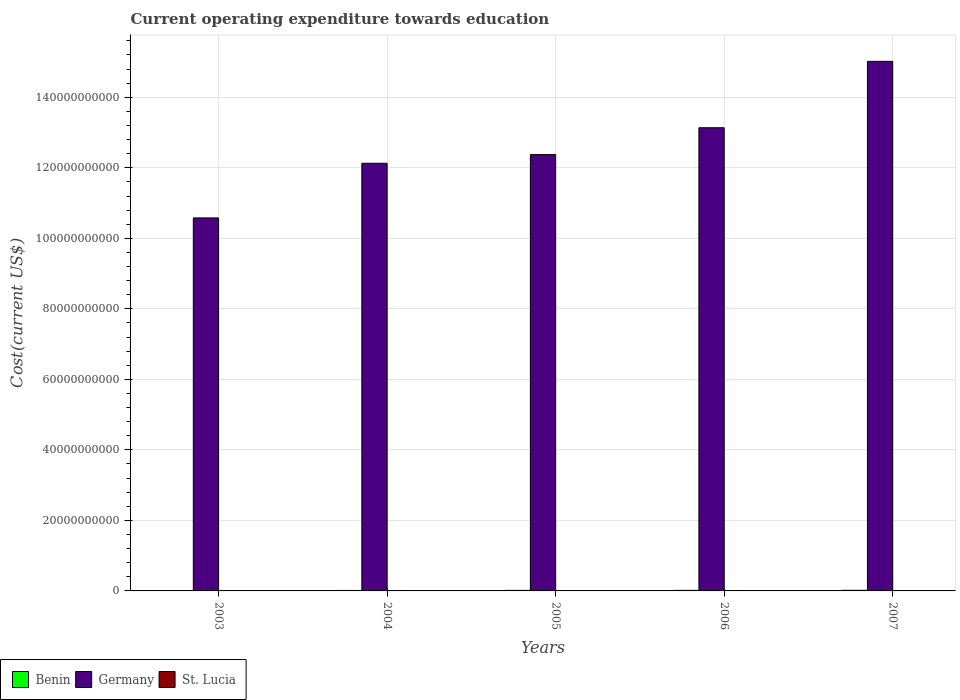Are the number of bars on each tick of the X-axis equal?
Provide a succinct answer. Yes. How many bars are there on the 5th tick from the right?
Offer a terse response. 3. What is the label of the 1st group of bars from the left?
Offer a very short reply. 2003. In how many cases, is the number of bars for a given year not equal to the number of legend labels?
Provide a short and direct response. 0. What is the expenditure towards education in St. Lucia in 2003?
Ensure brevity in your answer.  3.70e+07. Across all years, what is the maximum expenditure towards education in St. Lucia?
Provide a short and direct response. 4.95e+07. Across all years, what is the minimum expenditure towards education in Benin?
Keep it short and to the point. 9.85e+07. What is the total expenditure towards education in Benin in the graph?
Provide a succinct answer. 7.27e+08. What is the difference between the expenditure towards education in Germany in 2004 and that in 2007?
Your answer should be compact. -2.89e+1. What is the difference between the expenditure towards education in Germany in 2007 and the expenditure towards education in St. Lucia in 2004?
Provide a short and direct response. 1.50e+11. What is the average expenditure towards education in St. Lucia per year?
Make the answer very short. 4.30e+07. In the year 2004, what is the difference between the expenditure towards education in St. Lucia and expenditure towards education in Benin?
Give a very brief answer. -9.49e+07. What is the ratio of the expenditure towards education in St. Lucia in 2004 to that in 2007?
Your answer should be very brief. 0.76. Is the difference between the expenditure towards education in St. Lucia in 2006 and 2007 greater than the difference between the expenditure towards education in Benin in 2006 and 2007?
Your response must be concise. Yes. What is the difference between the highest and the second highest expenditure towards education in Benin?
Provide a short and direct response. 1.24e+07. What is the difference between the highest and the lowest expenditure towards education in St. Lucia?
Make the answer very short. 1.25e+07. What does the 3rd bar from the left in 2005 represents?
Your answer should be very brief. St. Lucia. What does the 1st bar from the right in 2004 represents?
Your response must be concise. St. Lucia. Are all the bars in the graph horizontal?
Keep it short and to the point. No. What is the difference between two consecutive major ticks on the Y-axis?
Your response must be concise. 2.00e+1. Does the graph contain any zero values?
Your answer should be very brief. No. Where does the legend appear in the graph?
Make the answer very short. Bottom left. How are the legend labels stacked?
Provide a short and direct response. Horizontal. What is the title of the graph?
Ensure brevity in your answer.  Current operating expenditure towards education. What is the label or title of the X-axis?
Offer a terse response. Years. What is the label or title of the Y-axis?
Your answer should be very brief. Cost(current US$). What is the Cost(current US$) in Benin in 2003?
Offer a very short reply. 9.85e+07. What is the Cost(current US$) in Germany in 2003?
Your answer should be compact. 1.06e+11. What is the Cost(current US$) of St. Lucia in 2003?
Make the answer very short. 3.70e+07. What is the Cost(current US$) of Benin in 2004?
Provide a short and direct response. 1.32e+08. What is the Cost(current US$) of Germany in 2004?
Give a very brief answer. 1.21e+11. What is the Cost(current US$) in St. Lucia in 2004?
Your answer should be very brief. 3.75e+07. What is the Cost(current US$) in Benin in 2005?
Keep it short and to the point. 1.56e+08. What is the Cost(current US$) in Germany in 2005?
Keep it short and to the point. 1.24e+11. What is the Cost(current US$) in St. Lucia in 2005?
Your response must be concise. 4.49e+07. What is the Cost(current US$) of Benin in 2006?
Offer a very short reply. 1.64e+08. What is the Cost(current US$) of Germany in 2006?
Your answer should be compact. 1.31e+11. What is the Cost(current US$) in St. Lucia in 2006?
Keep it short and to the point. 4.62e+07. What is the Cost(current US$) of Benin in 2007?
Your answer should be very brief. 1.76e+08. What is the Cost(current US$) in Germany in 2007?
Your answer should be compact. 1.50e+11. What is the Cost(current US$) in St. Lucia in 2007?
Ensure brevity in your answer.  4.95e+07. Across all years, what is the maximum Cost(current US$) in Benin?
Give a very brief answer. 1.76e+08. Across all years, what is the maximum Cost(current US$) of Germany?
Keep it short and to the point. 1.50e+11. Across all years, what is the maximum Cost(current US$) of St. Lucia?
Your response must be concise. 4.95e+07. Across all years, what is the minimum Cost(current US$) of Benin?
Your answer should be compact. 9.85e+07. Across all years, what is the minimum Cost(current US$) of Germany?
Offer a very short reply. 1.06e+11. Across all years, what is the minimum Cost(current US$) of St. Lucia?
Offer a terse response. 3.70e+07. What is the total Cost(current US$) in Benin in the graph?
Provide a succinct answer. 7.27e+08. What is the total Cost(current US$) in Germany in the graph?
Offer a terse response. 6.32e+11. What is the total Cost(current US$) in St. Lucia in the graph?
Your response must be concise. 2.15e+08. What is the difference between the Cost(current US$) of Benin in 2003 and that in 2004?
Keep it short and to the point. -3.39e+07. What is the difference between the Cost(current US$) in Germany in 2003 and that in 2004?
Your answer should be very brief. -1.55e+1. What is the difference between the Cost(current US$) of St. Lucia in 2003 and that in 2004?
Provide a short and direct response. -5.53e+05. What is the difference between the Cost(current US$) in Benin in 2003 and that in 2005?
Give a very brief answer. -5.77e+07. What is the difference between the Cost(current US$) of Germany in 2003 and that in 2005?
Provide a short and direct response. -1.80e+1. What is the difference between the Cost(current US$) in St. Lucia in 2003 and that in 2005?
Your response must be concise. -7.88e+06. What is the difference between the Cost(current US$) in Benin in 2003 and that in 2006?
Give a very brief answer. -6.51e+07. What is the difference between the Cost(current US$) of Germany in 2003 and that in 2006?
Your response must be concise. -2.56e+1. What is the difference between the Cost(current US$) of St. Lucia in 2003 and that in 2006?
Your answer should be very brief. -9.24e+06. What is the difference between the Cost(current US$) in Benin in 2003 and that in 2007?
Provide a succinct answer. -7.76e+07. What is the difference between the Cost(current US$) of Germany in 2003 and that in 2007?
Your response must be concise. -4.44e+1. What is the difference between the Cost(current US$) in St. Lucia in 2003 and that in 2007?
Ensure brevity in your answer.  -1.25e+07. What is the difference between the Cost(current US$) of Benin in 2004 and that in 2005?
Offer a terse response. -2.38e+07. What is the difference between the Cost(current US$) in Germany in 2004 and that in 2005?
Your answer should be compact. -2.46e+09. What is the difference between the Cost(current US$) of St. Lucia in 2004 and that in 2005?
Your response must be concise. -7.33e+06. What is the difference between the Cost(current US$) of Benin in 2004 and that in 2006?
Offer a terse response. -3.12e+07. What is the difference between the Cost(current US$) of Germany in 2004 and that in 2006?
Provide a succinct answer. -1.01e+1. What is the difference between the Cost(current US$) in St. Lucia in 2004 and that in 2006?
Your answer should be very brief. -8.69e+06. What is the difference between the Cost(current US$) of Benin in 2004 and that in 2007?
Offer a terse response. -4.36e+07. What is the difference between the Cost(current US$) in Germany in 2004 and that in 2007?
Offer a very short reply. -2.89e+1. What is the difference between the Cost(current US$) of St. Lucia in 2004 and that in 2007?
Ensure brevity in your answer.  -1.19e+07. What is the difference between the Cost(current US$) in Benin in 2005 and that in 2006?
Give a very brief answer. -7.40e+06. What is the difference between the Cost(current US$) of Germany in 2005 and that in 2006?
Offer a terse response. -7.61e+09. What is the difference between the Cost(current US$) in St. Lucia in 2005 and that in 2006?
Your answer should be compact. -1.36e+06. What is the difference between the Cost(current US$) in Benin in 2005 and that in 2007?
Keep it short and to the point. -1.98e+07. What is the difference between the Cost(current US$) in Germany in 2005 and that in 2007?
Your answer should be compact. -2.64e+1. What is the difference between the Cost(current US$) of St. Lucia in 2005 and that in 2007?
Give a very brief answer. -4.60e+06. What is the difference between the Cost(current US$) in Benin in 2006 and that in 2007?
Ensure brevity in your answer.  -1.24e+07. What is the difference between the Cost(current US$) of Germany in 2006 and that in 2007?
Give a very brief answer. -1.88e+1. What is the difference between the Cost(current US$) in St. Lucia in 2006 and that in 2007?
Provide a short and direct response. -3.24e+06. What is the difference between the Cost(current US$) in Benin in 2003 and the Cost(current US$) in Germany in 2004?
Give a very brief answer. -1.21e+11. What is the difference between the Cost(current US$) of Benin in 2003 and the Cost(current US$) of St. Lucia in 2004?
Make the answer very short. 6.10e+07. What is the difference between the Cost(current US$) of Germany in 2003 and the Cost(current US$) of St. Lucia in 2004?
Your answer should be very brief. 1.06e+11. What is the difference between the Cost(current US$) of Benin in 2003 and the Cost(current US$) of Germany in 2005?
Provide a succinct answer. -1.24e+11. What is the difference between the Cost(current US$) of Benin in 2003 and the Cost(current US$) of St. Lucia in 2005?
Your answer should be very brief. 5.37e+07. What is the difference between the Cost(current US$) in Germany in 2003 and the Cost(current US$) in St. Lucia in 2005?
Give a very brief answer. 1.06e+11. What is the difference between the Cost(current US$) of Benin in 2003 and the Cost(current US$) of Germany in 2006?
Make the answer very short. -1.31e+11. What is the difference between the Cost(current US$) in Benin in 2003 and the Cost(current US$) in St. Lucia in 2006?
Keep it short and to the point. 5.23e+07. What is the difference between the Cost(current US$) of Germany in 2003 and the Cost(current US$) of St. Lucia in 2006?
Offer a terse response. 1.06e+11. What is the difference between the Cost(current US$) in Benin in 2003 and the Cost(current US$) in Germany in 2007?
Provide a short and direct response. -1.50e+11. What is the difference between the Cost(current US$) in Benin in 2003 and the Cost(current US$) in St. Lucia in 2007?
Provide a succinct answer. 4.91e+07. What is the difference between the Cost(current US$) in Germany in 2003 and the Cost(current US$) in St. Lucia in 2007?
Make the answer very short. 1.06e+11. What is the difference between the Cost(current US$) in Benin in 2004 and the Cost(current US$) in Germany in 2005?
Give a very brief answer. -1.24e+11. What is the difference between the Cost(current US$) in Benin in 2004 and the Cost(current US$) in St. Lucia in 2005?
Keep it short and to the point. 8.76e+07. What is the difference between the Cost(current US$) of Germany in 2004 and the Cost(current US$) of St. Lucia in 2005?
Give a very brief answer. 1.21e+11. What is the difference between the Cost(current US$) in Benin in 2004 and the Cost(current US$) in Germany in 2006?
Ensure brevity in your answer.  -1.31e+11. What is the difference between the Cost(current US$) in Benin in 2004 and the Cost(current US$) in St. Lucia in 2006?
Your answer should be very brief. 8.62e+07. What is the difference between the Cost(current US$) in Germany in 2004 and the Cost(current US$) in St. Lucia in 2006?
Provide a succinct answer. 1.21e+11. What is the difference between the Cost(current US$) of Benin in 2004 and the Cost(current US$) of Germany in 2007?
Your answer should be very brief. -1.50e+11. What is the difference between the Cost(current US$) of Benin in 2004 and the Cost(current US$) of St. Lucia in 2007?
Ensure brevity in your answer.  8.30e+07. What is the difference between the Cost(current US$) of Germany in 2004 and the Cost(current US$) of St. Lucia in 2007?
Provide a short and direct response. 1.21e+11. What is the difference between the Cost(current US$) of Benin in 2005 and the Cost(current US$) of Germany in 2006?
Your answer should be compact. -1.31e+11. What is the difference between the Cost(current US$) in Benin in 2005 and the Cost(current US$) in St. Lucia in 2006?
Provide a short and direct response. 1.10e+08. What is the difference between the Cost(current US$) of Germany in 2005 and the Cost(current US$) of St. Lucia in 2006?
Ensure brevity in your answer.  1.24e+11. What is the difference between the Cost(current US$) of Benin in 2005 and the Cost(current US$) of Germany in 2007?
Keep it short and to the point. -1.50e+11. What is the difference between the Cost(current US$) of Benin in 2005 and the Cost(current US$) of St. Lucia in 2007?
Keep it short and to the point. 1.07e+08. What is the difference between the Cost(current US$) of Germany in 2005 and the Cost(current US$) of St. Lucia in 2007?
Provide a short and direct response. 1.24e+11. What is the difference between the Cost(current US$) in Benin in 2006 and the Cost(current US$) in Germany in 2007?
Provide a short and direct response. -1.50e+11. What is the difference between the Cost(current US$) of Benin in 2006 and the Cost(current US$) of St. Lucia in 2007?
Make the answer very short. 1.14e+08. What is the difference between the Cost(current US$) of Germany in 2006 and the Cost(current US$) of St. Lucia in 2007?
Provide a succinct answer. 1.31e+11. What is the average Cost(current US$) of Benin per year?
Offer a terse response. 1.45e+08. What is the average Cost(current US$) of Germany per year?
Your response must be concise. 1.26e+11. What is the average Cost(current US$) in St. Lucia per year?
Ensure brevity in your answer.  4.30e+07. In the year 2003, what is the difference between the Cost(current US$) of Benin and Cost(current US$) of Germany?
Ensure brevity in your answer.  -1.06e+11. In the year 2003, what is the difference between the Cost(current US$) of Benin and Cost(current US$) of St. Lucia?
Your answer should be compact. 6.15e+07. In the year 2003, what is the difference between the Cost(current US$) in Germany and Cost(current US$) in St. Lucia?
Offer a very short reply. 1.06e+11. In the year 2004, what is the difference between the Cost(current US$) in Benin and Cost(current US$) in Germany?
Your answer should be very brief. -1.21e+11. In the year 2004, what is the difference between the Cost(current US$) in Benin and Cost(current US$) in St. Lucia?
Your answer should be very brief. 9.49e+07. In the year 2004, what is the difference between the Cost(current US$) of Germany and Cost(current US$) of St. Lucia?
Offer a very short reply. 1.21e+11. In the year 2005, what is the difference between the Cost(current US$) of Benin and Cost(current US$) of Germany?
Your response must be concise. -1.24e+11. In the year 2005, what is the difference between the Cost(current US$) in Benin and Cost(current US$) in St. Lucia?
Your answer should be very brief. 1.11e+08. In the year 2005, what is the difference between the Cost(current US$) of Germany and Cost(current US$) of St. Lucia?
Provide a succinct answer. 1.24e+11. In the year 2006, what is the difference between the Cost(current US$) of Benin and Cost(current US$) of Germany?
Your answer should be compact. -1.31e+11. In the year 2006, what is the difference between the Cost(current US$) of Benin and Cost(current US$) of St. Lucia?
Offer a very short reply. 1.17e+08. In the year 2006, what is the difference between the Cost(current US$) in Germany and Cost(current US$) in St. Lucia?
Offer a terse response. 1.31e+11. In the year 2007, what is the difference between the Cost(current US$) of Benin and Cost(current US$) of Germany?
Give a very brief answer. -1.50e+11. In the year 2007, what is the difference between the Cost(current US$) in Benin and Cost(current US$) in St. Lucia?
Your answer should be compact. 1.27e+08. In the year 2007, what is the difference between the Cost(current US$) in Germany and Cost(current US$) in St. Lucia?
Your answer should be compact. 1.50e+11. What is the ratio of the Cost(current US$) in Benin in 2003 to that in 2004?
Make the answer very short. 0.74. What is the ratio of the Cost(current US$) of Germany in 2003 to that in 2004?
Provide a succinct answer. 0.87. What is the ratio of the Cost(current US$) in Benin in 2003 to that in 2005?
Your answer should be compact. 0.63. What is the ratio of the Cost(current US$) of Germany in 2003 to that in 2005?
Provide a short and direct response. 0.85. What is the ratio of the Cost(current US$) of St. Lucia in 2003 to that in 2005?
Provide a succinct answer. 0.82. What is the ratio of the Cost(current US$) of Benin in 2003 to that in 2006?
Offer a terse response. 0.6. What is the ratio of the Cost(current US$) in Germany in 2003 to that in 2006?
Your answer should be very brief. 0.81. What is the ratio of the Cost(current US$) of St. Lucia in 2003 to that in 2006?
Offer a terse response. 0.8. What is the ratio of the Cost(current US$) in Benin in 2003 to that in 2007?
Ensure brevity in your answer.  0.56. What is the ratio of the Cost(current US$) in Germany in 2003 to that in 2007?
Your answer should be very brief. 0.7. What is the ratio of the Cost(current US$) of St. Lucia in 2003 to that in 2007?
Your response must be concise. 0.75. What is the ratio of the Cost(current US$) of Benin in 2004 to that in 2005?
Your answer should be compact. 0.85. What is the ratio of the Cost(current US$) of Germany in 2004 to that in 2005?
Provide a succinct answer. 0.98. What is the ratio of the Cost(current US$) of St. Lucia in 2004 to that in 2005?
Provide a succinct answer. 0.84. What is the ratio of the Cost(current US$) in Benin in 2004 to that in 2006?
Keep it short and to the point. 0.81. What is the ratio of the Cost(current US$) in Germany in 2004 to that in 2006?
Offer a very short reply. 0.92. What is the ratio of the Cost(current US$) of St. Lucia in 2004 to that in 2006?
Your response must be concise. 0.81. What is the ratio of the Cost(current US$) in Benin in 2004 to that in 2007?
Keep it short and to the point. 0.75. What is the ratio of the Cost(current US$) of Germany in 2004 to that in 2007?
Give a very brief answer. 0.81. What is the ratio of the Cost(current US$) in St. Lucia in 2004 to that in 2007?
Your response must be concise. 0.76. What is the ratio of the Cost(current US$) of Benin in 2005 to that in 2006?
Offer a very short reply. 0.95. What is the ratio of the Cost(current US$) in Germany in 2005 to that in 2006?
Provide a short and direct response. 0.94. What is the ratio of the Cost(current US$) in St. Lucia in 2005 to that in 2006?
Your answer should be compact. 0.97. What is the ratio of the Cost(current US$) of Benin in 2005 to that in 2007?
Make the answer very short. 0.89. What is the ratio of the Cost(current US$) in Germany in 2005 to that in 2007?
Your answer should be compact. 0.82. What is the ratio of the Cost(current US$) in St. Lucia in 2005 to that in 2007?
Your response must be concise. 0.91. What is the ratio of the Cost(current US$) in Benin in 2006 to that in 2007?
Offer a terse response. 0.93. What is the ratio of the Cost(current US$) in Germany in 2006 to that in 2007?
Offer a very short reply. 0.87. What is the ratio of the Cost(current US$) of St. Lucia in 2006 to that in 2007?
Make the answer very short. 0.93. What is the difference between the highest and the second highest Cost(current US$) of Benin?
Offer a very short reply. 1.24e+07. What is the difference between the highest and the second highest Cost(current US$) of Germany?
Your answer should be compact. 1.88e+1. What is the difference between the highest and the second highest Cost(current US$) of St. Lucia?
Provide a short and direct response. 3.24e+06. What is the difference between the highest and the lowest Cost(current US$) of Benin?
Your answer should be compact. 7.76e+07. What is the difference between the highest and the lowest Cost(current US$) in Germany?
Give a very brief answer. 4.44e+1. What is the difference between the highest and the lowest Cost(current US$) of St. Lucia?
Ensure brevity in your answer.  1.25e+07. 